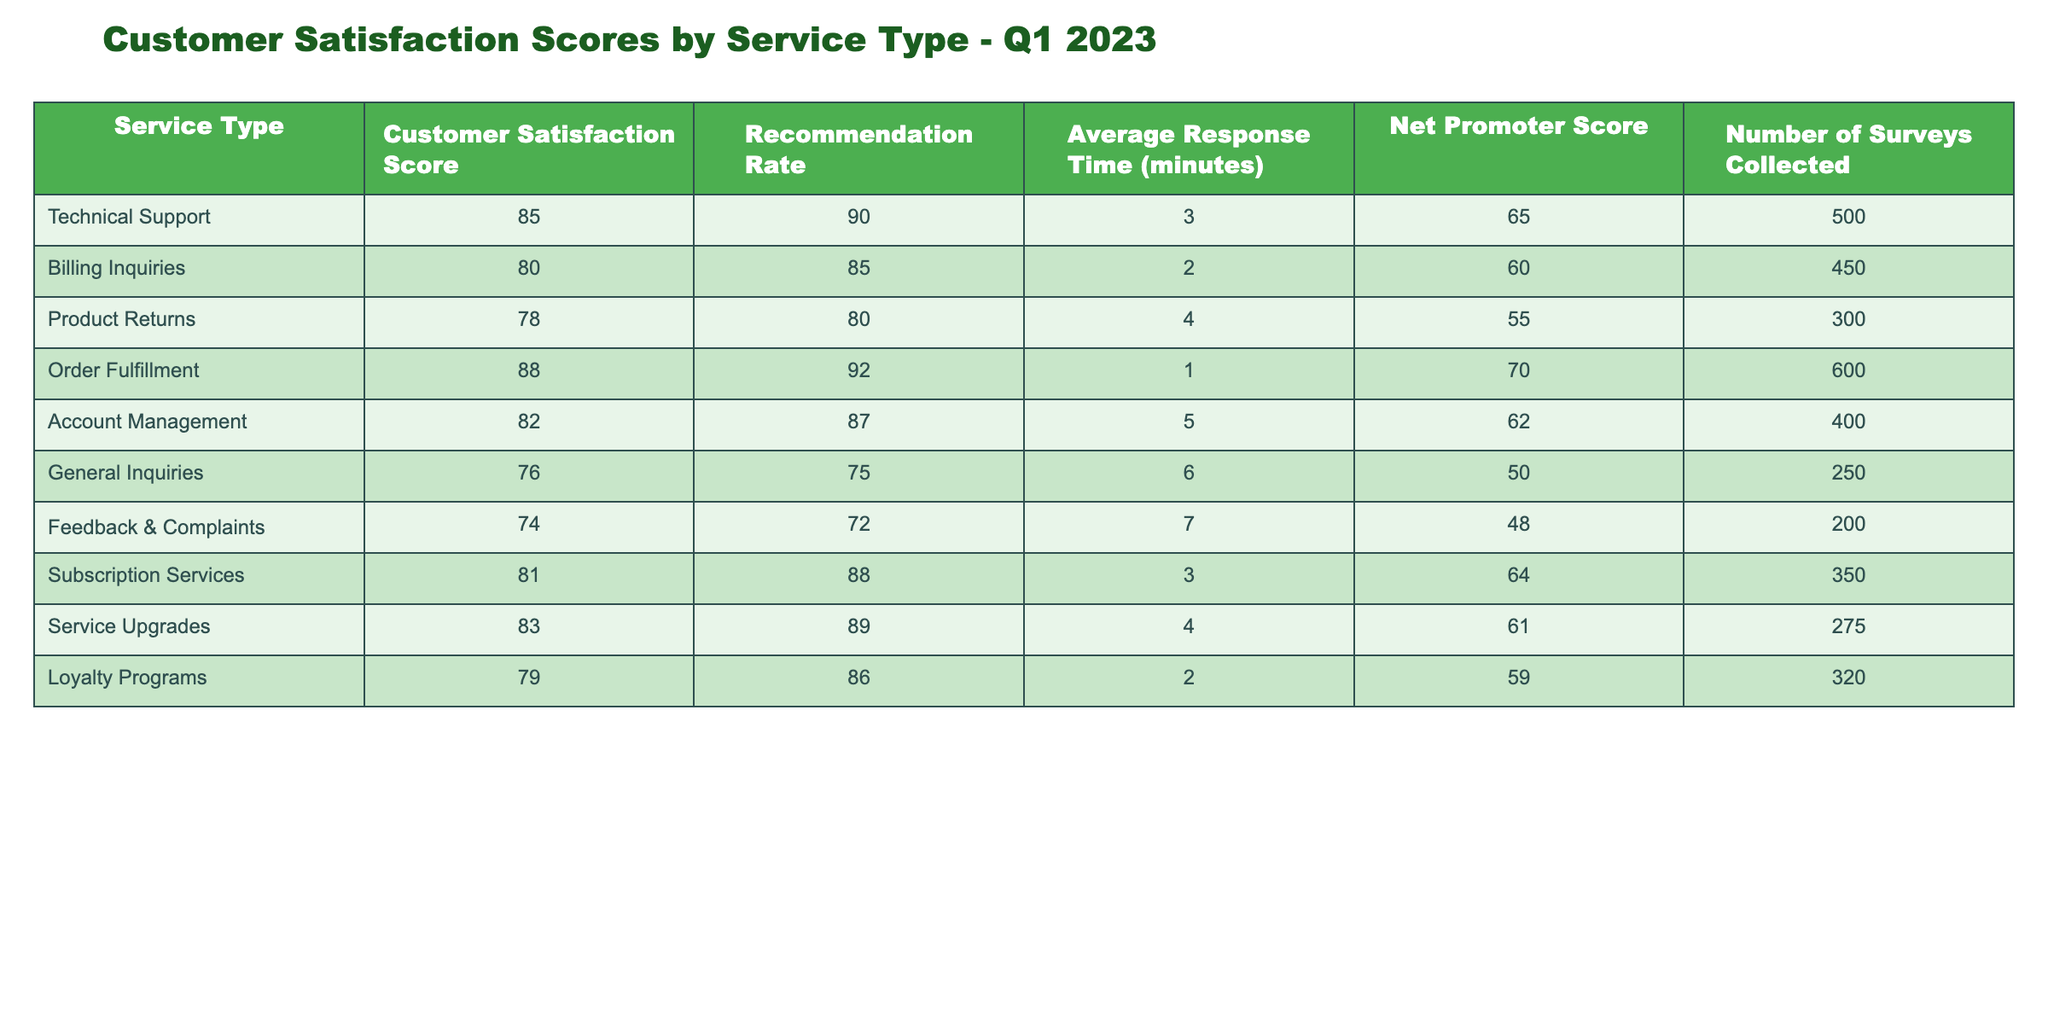What is the Customer Satisfaction Score for Order Fulfillment? The Customer Satisfaction Score for Order Fulfillment is provided in the table as 88.
Answer: 88 How many surveys were collected for Technical Support? The number of surveys collected for Technical Support is listed in the table as 500.
Answer: 500 What service type has the highest Recommendation Rate? By reviewing the Recommendation Rates in the table, Order Fulfillment has the highest rate at 92.
Answer: Order Fulfillment What is the average Customer Satisfaction Score across all service types? To find the average, sum up all the Customer Satisfaction Scores: (85 + 80 + 78 + 88 + 82 + 76 + 74 + 81 + 83 + 79) = 815, then divide by the number of service types (10): 815 / 10 = 81.5.
Answer: 81.5 Is the Net Promoter Score for Subscription Services greater than 60? The Net Promoter Score for Subscription Services is 64, which is indeed greater than 60.
Answer: Yes What is the difference in Customer Satisfaction Scores between Technical Support and Feedback & Complaints? The Customer Satisfaction Score for Technical Support is 85, and for Feedback & Complaints, it is 74. The difference is 85 - 74 = 11.
Answer: 11 Which service type has the longest Average Response Time, and what is that time? Comparing all the Average Response Times, General Inquiries has the longest at 6 minutes.
Answer: General Inquiries, 6 minutes If the Recommendation Rates for Product Returns and Loyalty Programs are summed, what is the total? The Recommendation Rate for Product Returns is 80, and for Loyalty Programs, it is 86. Summing them gives 80 + 86 = 166.
Answer: 166 What is the average Recommendation Rate for service types with a Customer Satisfaction Score above 80? The service types with a Customer Satisfaction Score above 80 are Technical Support (90), Order Fulfillment (92), Account Management (87), Subscription Services (88), and Service Upgrades (89). Summing these Recommendation Rates gives 90 + 92 + 87 + 88 + 89 = 446, then dividing by 5 gives 446 / 5 = 89.2.
Answer: 89.2 Which service type has the lowest Net Promoter Score, and what is its value? The service type with the lowest Net Promoter Score is Feedback & Complaints at 48.
Answer: Feedback & Complaints, 48 